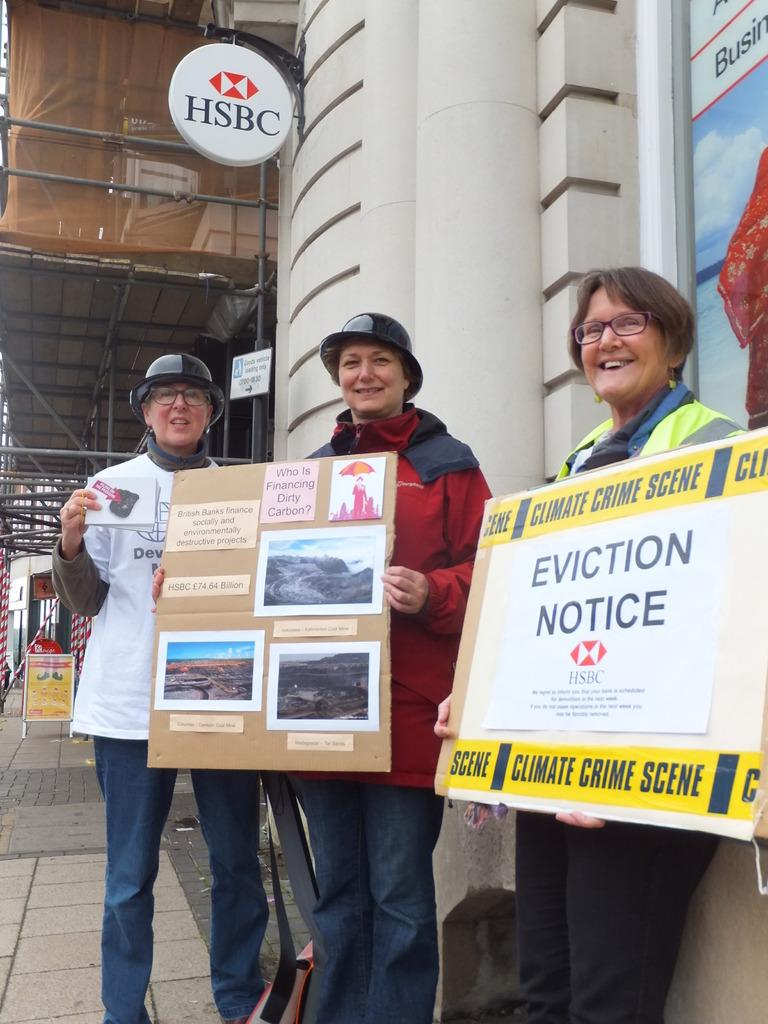What are the people in the image doing? The people in the image are standing and holding banners. What can be seen in the background of the image? There is a building in the background of the image. What is located on the left side of the image? There is a board on the left side of the image. Can you tell me how many toothbrushes are visible in the image? There are no toothbrushes present in the image. What type of drum is being played by the people in the image? There is no drum present in the image; the people are holding banners. 